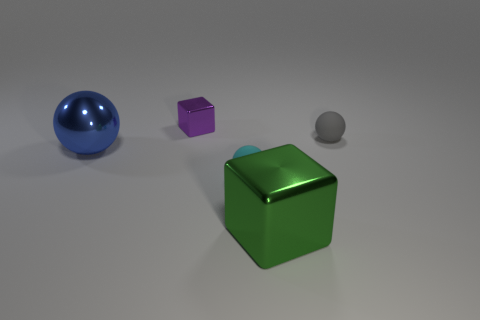Add 5 small shiny things. How many objects exist? 10 Subtract all blocks. How many objects are left? 3 Add 3 big metal things. How many big metal things are left? 5 Add 1 green things. How many green things exist? 2 Subtract 0 purple spheres. How many objects are left? 5 Subtract all metal blocks. Subtract all tiny blocks. How many objects are left? 2 